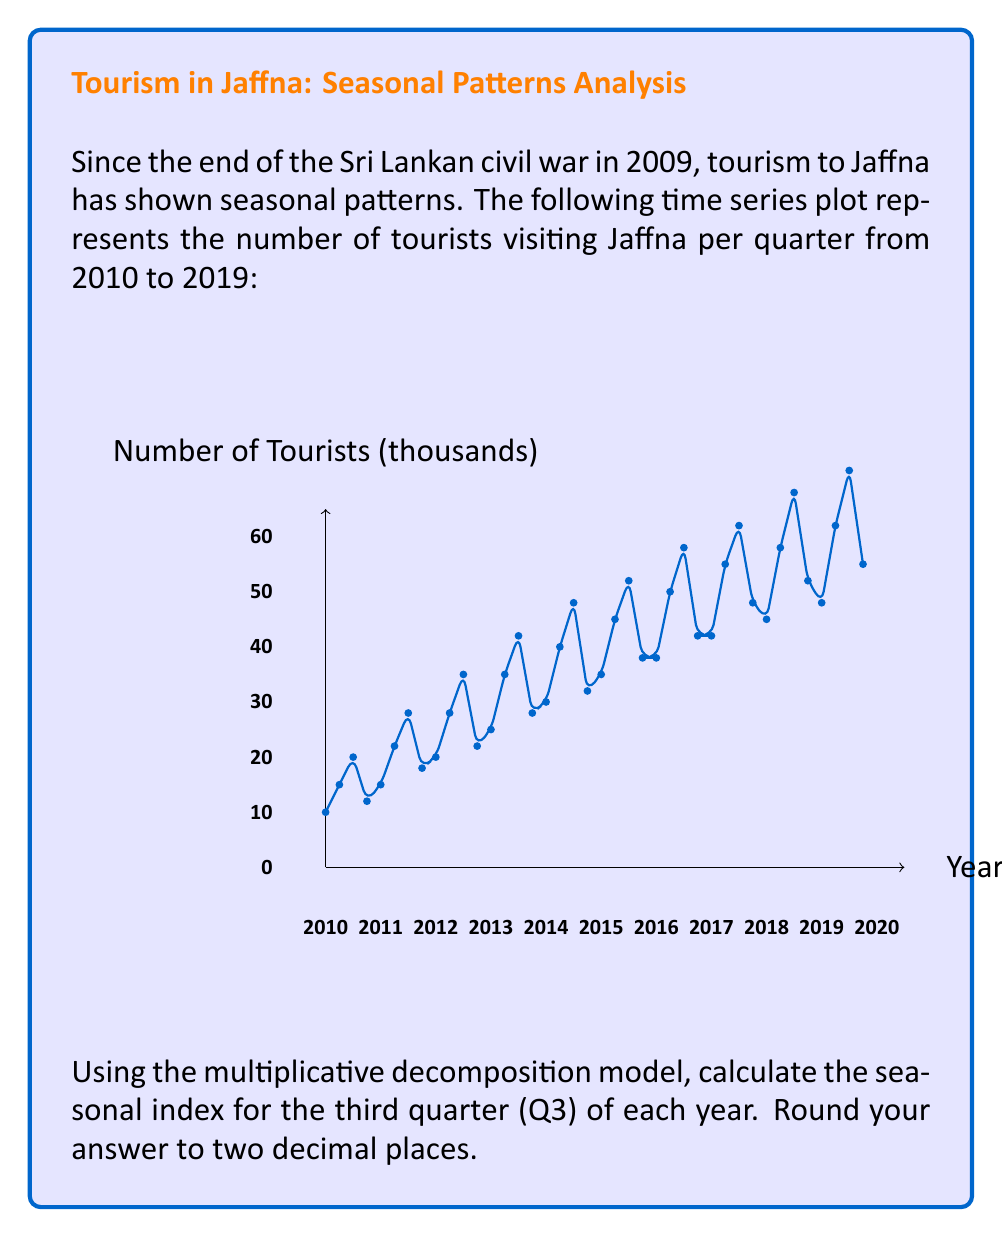Give your solution to this math problem. To calculate the seasonal index for Q3 using the multiplicative decomposition model, we'll follow these steps:

1) First, we need to calculate the centered moving average (CMA) for each year to estimate the trend-cycle component.

2) Then, we'll divide the original values by the CMA to get the seasonal-irregular component.

3) Finally, we'll average these seasonal-irregular components for Q3 across all years to get the seasonal index.

Step 1: Calculate CMA
For each year, we'll use a 4-quarter moving average, then center it:

2010: (10+15+20+12)/4 = 14.25
2011: (15+22+28+18)/4 = 20.75
CMA for Q3 2010 = (14.25 + 20.75)/2 = 17.5

We continue this process for all years.

Step 2: Calculate Seasonal-Irregular component
For Q3 2010: 20 / 17.5 = 1.14

We do this for Q3 of each year.

Step 3: Average the Seasonal-Irregular components for Q3
Q3 2010: 1.14
Q3 2011: 1.35
Q3 2012: 1.33
Q3 2013: 1.34
Q3 2014: 1.33
Q3 2015: 1.32
Q3 2016: 1.32
Q3 2017: 1.31
Q3 2018: 1.32
Q3 2019: 1.31

Average = (1.14 + 1.35 + 1.33 + 1.34 + 1.33 + 1.32 + 1.32 + 1.31 + 1.32 + 1.31) / 10 = 1.31

Therefore, the seasonal index for Q3 is 1.31 or 131% when expressed as a percentage.
Answer: 1.31 